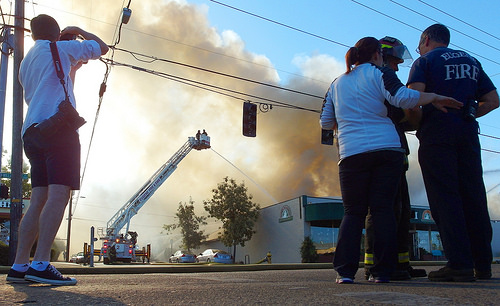<image>
Is there a fire truck behind the traffic light? Yes. From this viewpoint, the fire truck is positioned behind the traffic light, with the traffic light partially or fully occluding the fire truck. 